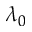Convert formula to latex. <formula><loc_0><loc_0><loc_500><loc_500>\lambda _ { 0 }</formula> 